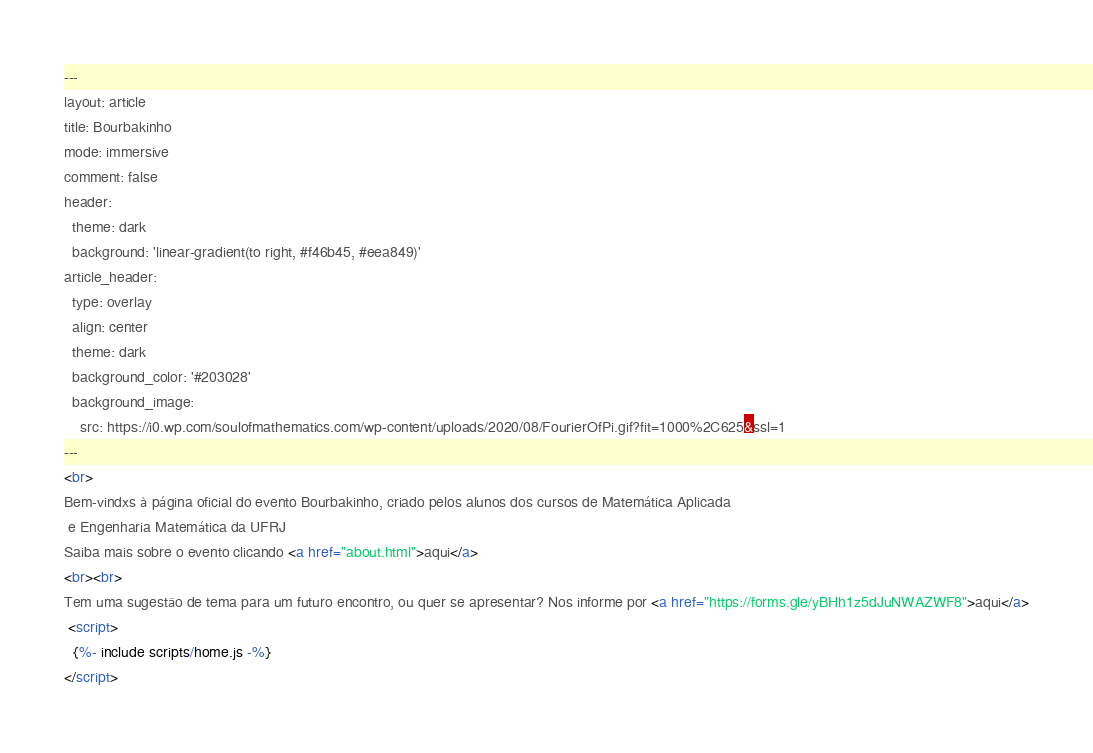Convert code to text. <code><loc_0><loc_0><loc_500><loc_500><_HTML_>---
layout: article
title: Bourbakinho
mode: immersive
comment: false
header:
  theme: dark
  background: 'linear-gradient(to right, #f46b45, #eea849)'
article_header:
  type: overlay
  align: center
  theme: dark
  background_color: '#203028'
  background_image:
    src: https://i0.wp.com/soulofmathematics.com/wp-content/uploads/2020/08/FourierOfPi.gif?fit=1000%2C625&ssl=1
---
<br>
Bem-vindxs à página oficial do evento Bourbakinho, criado pelos alunos dos cursos de Matemática Aplicada
 e Engenharia Matemática da UFRJ
Saiba mais sobre o evento clicando <a href="about.html">aqui</a>
<br><br>
Tem uma sugestão de tema para um futuro encontro, ou quer se apresentar? Nos informe por <a href="https://forms.gle/yBHh1z5dJuNWAZWF8">aqui</a>
 <script>
  {%- include scripts/home.js -%}
</script></code> 